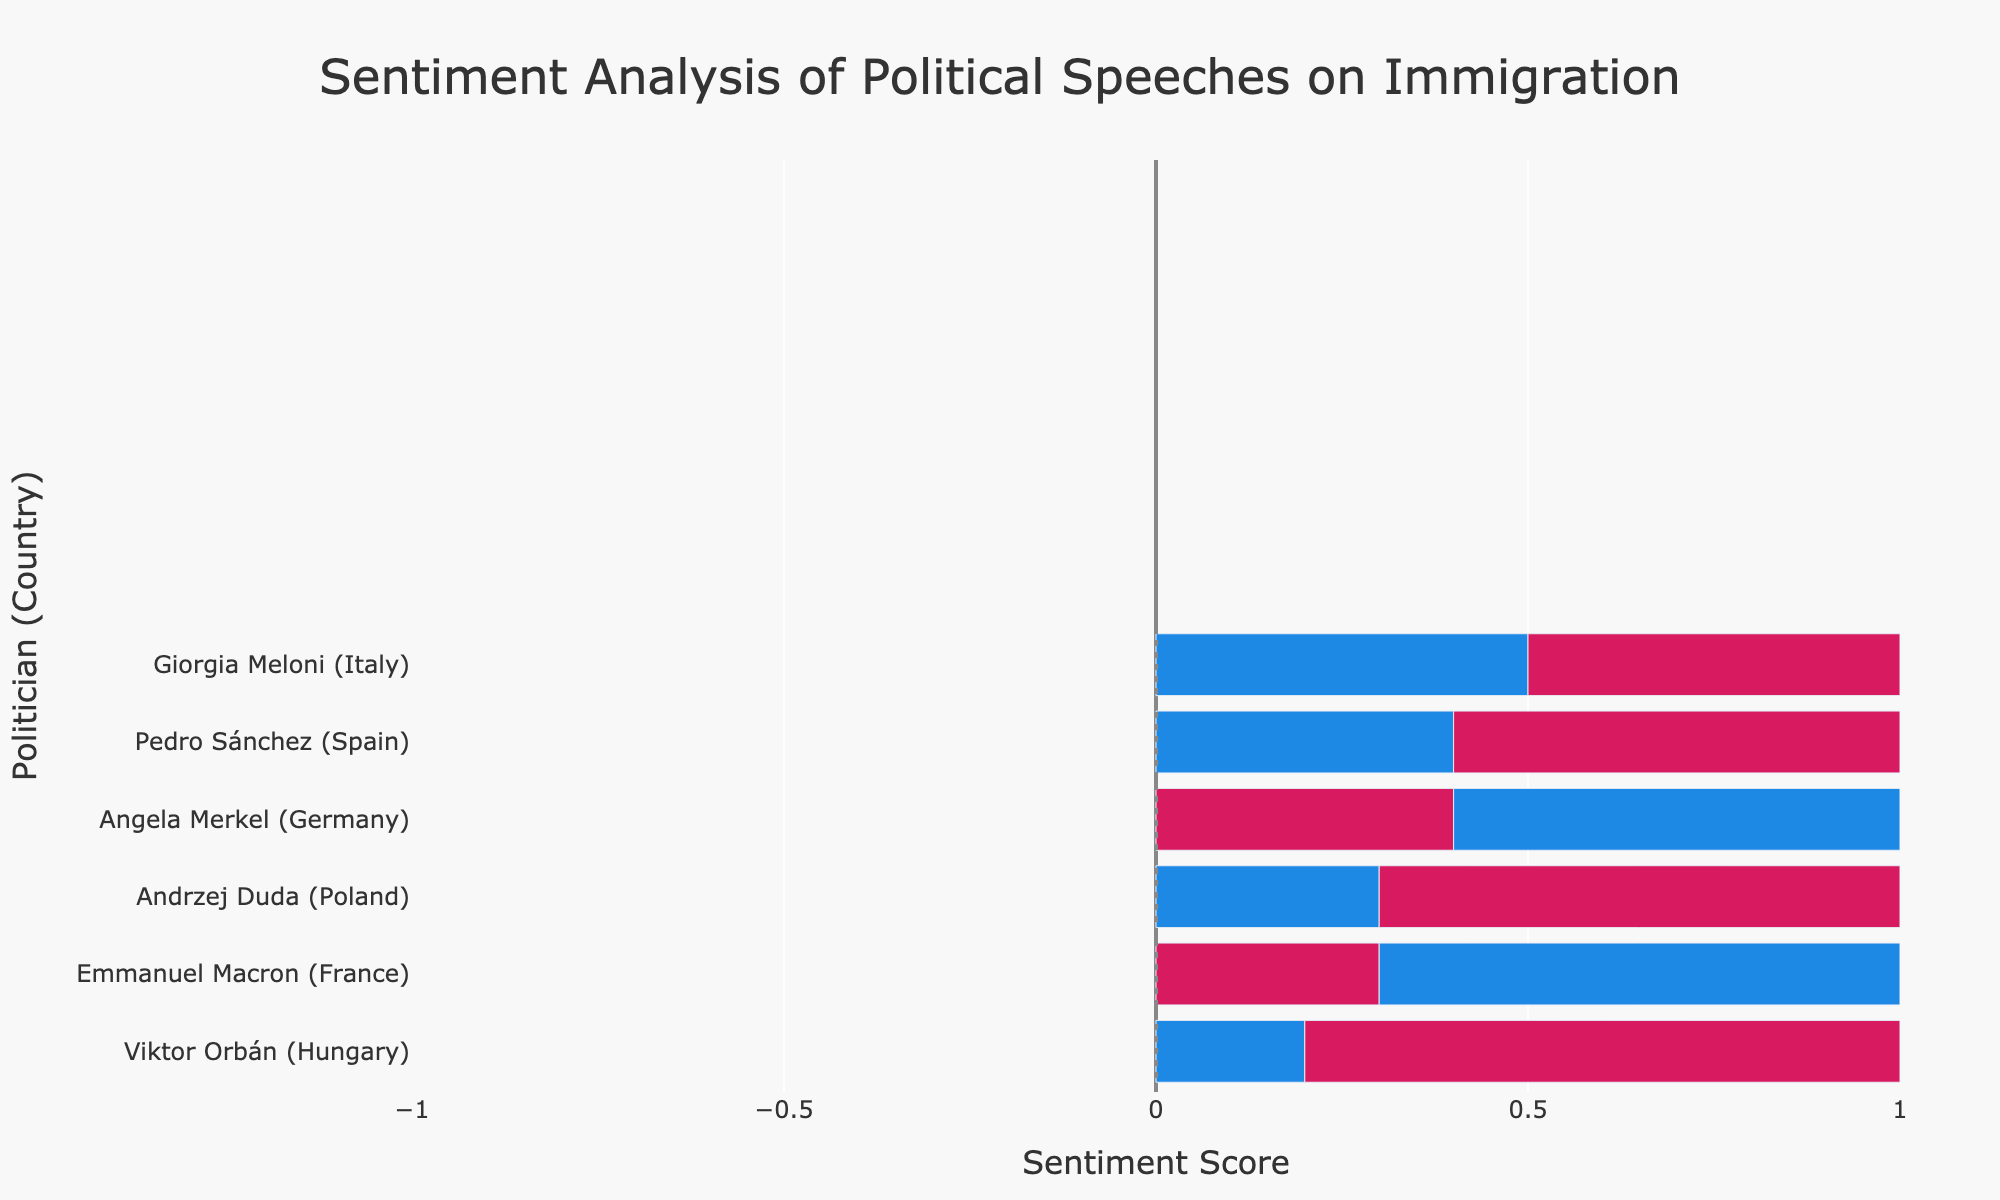What is the highest positive sentiment score presented in the plot, and which politician does it belong to? The highest positive sentiment score is represented by the longest blue bar on the positive side of the chart. By looking at the chart, Emmanuel Macron from France has the longest blue bar with a sentiment score of 0.7.
Answer: 0.7 (Emmanuel Macron) Which two politicians have the most negative sentiment scores, and what are those scores? The most negative sentiment scores are represented by the longest red bars on the negative side of the chart. Andrzej Duda (Poland) and Viktor Orbán (Hungary) have the longest red bars with sentiment scores of -0.7 and -0.8, respectively.
Answer: Andrzej Duda: -0.7, Viktor Orbán: -0.8 Which politician has the smallest difference between positive and negative sentiment scores? To find the smallest difference, calculate the absolute difference between the positive and negative sentiment scores for each politician. Angela Merkel's positive score is 0.6 and her negative score is -0.4, resulting in a difference of 0.6 - 0.4 = 0.2. Emmanuel Macron has a difference of 0.7 - 0.3 = 0.4. Giorgia Meloni's difference is 0.5 - 0.5 = 0. The smallest difference is thus for Giorgia Meloni.
Answer: Giorgia Meloni Which politician from Spain has a higher absolute sentiment score, positive or negative, and what is the value? Compare the absolute values of the positive and negative sentiment scores for Pedro Sánchez from Spain. The chart shows Pedro Sánchez has a positive score of 0.4 and a negative score of -0.6. The absolute values are 0.4 and 0.6, respectively, so the negative sentiment score is higher.
Answer: Negative (-0.6) What is the combined average sentiment score for the politicians from Germany and France? First, sum up the sentiment scores for Angela Merkel (0.6, -0.4) and Emmanuel Macron (0.7, -0.3): 0.6 + (-0.4) + 0.7 + (-0.3) = 0.6. There are four scores in total, so the average is 0.6 / 4 = 0.15.
Answer: 0.15 How many politicians have a positive sentiment score higher than 0.5? Check the positive sentiment scores greater than 0.5 in the plot. Angela Merkel (0.6) and Emmanuel Macron (0.7) both have positive scores higher than 0.5.
Answer: 2 Between Italy and Hungary, which country's politician has a more extreme negative sentiment score, and what is the score? Compare the negative sentiment scores for Giorgia Meloni from Italy (-0.5) and Viktor Orbán from Hungary (-0.8). Viktor Orbán has the more extreme negative sentiment score.
Answer: Hungary (-0.8) What's the total sum of all the positive sentiment scores shown in the chart? Sum the positive sentiment scores from each politician: 0.6 (Angela Merkel) + 0.7 (Emmanuel Macron) + 0.5 (Giorgia Meloni) + 0.4 (Pedro Sánchez) + 0.3 (Andrzej Duda) + 0.2 (Viktor Orbán) = 2.7.
Answer: 2.7 Which is greater, the absolute value of the most negative sentiment score or the highest positive sentiment score, and by how much? The most negative sentiment score is -0.8 (absolute value 0.8), and the highest positive sentiment score is 0.7. The absolute value of the most negative sentiment score is greater. The difference is 0.8 - 0.7 = 0.1.
Answer: Most negative by 0.1 